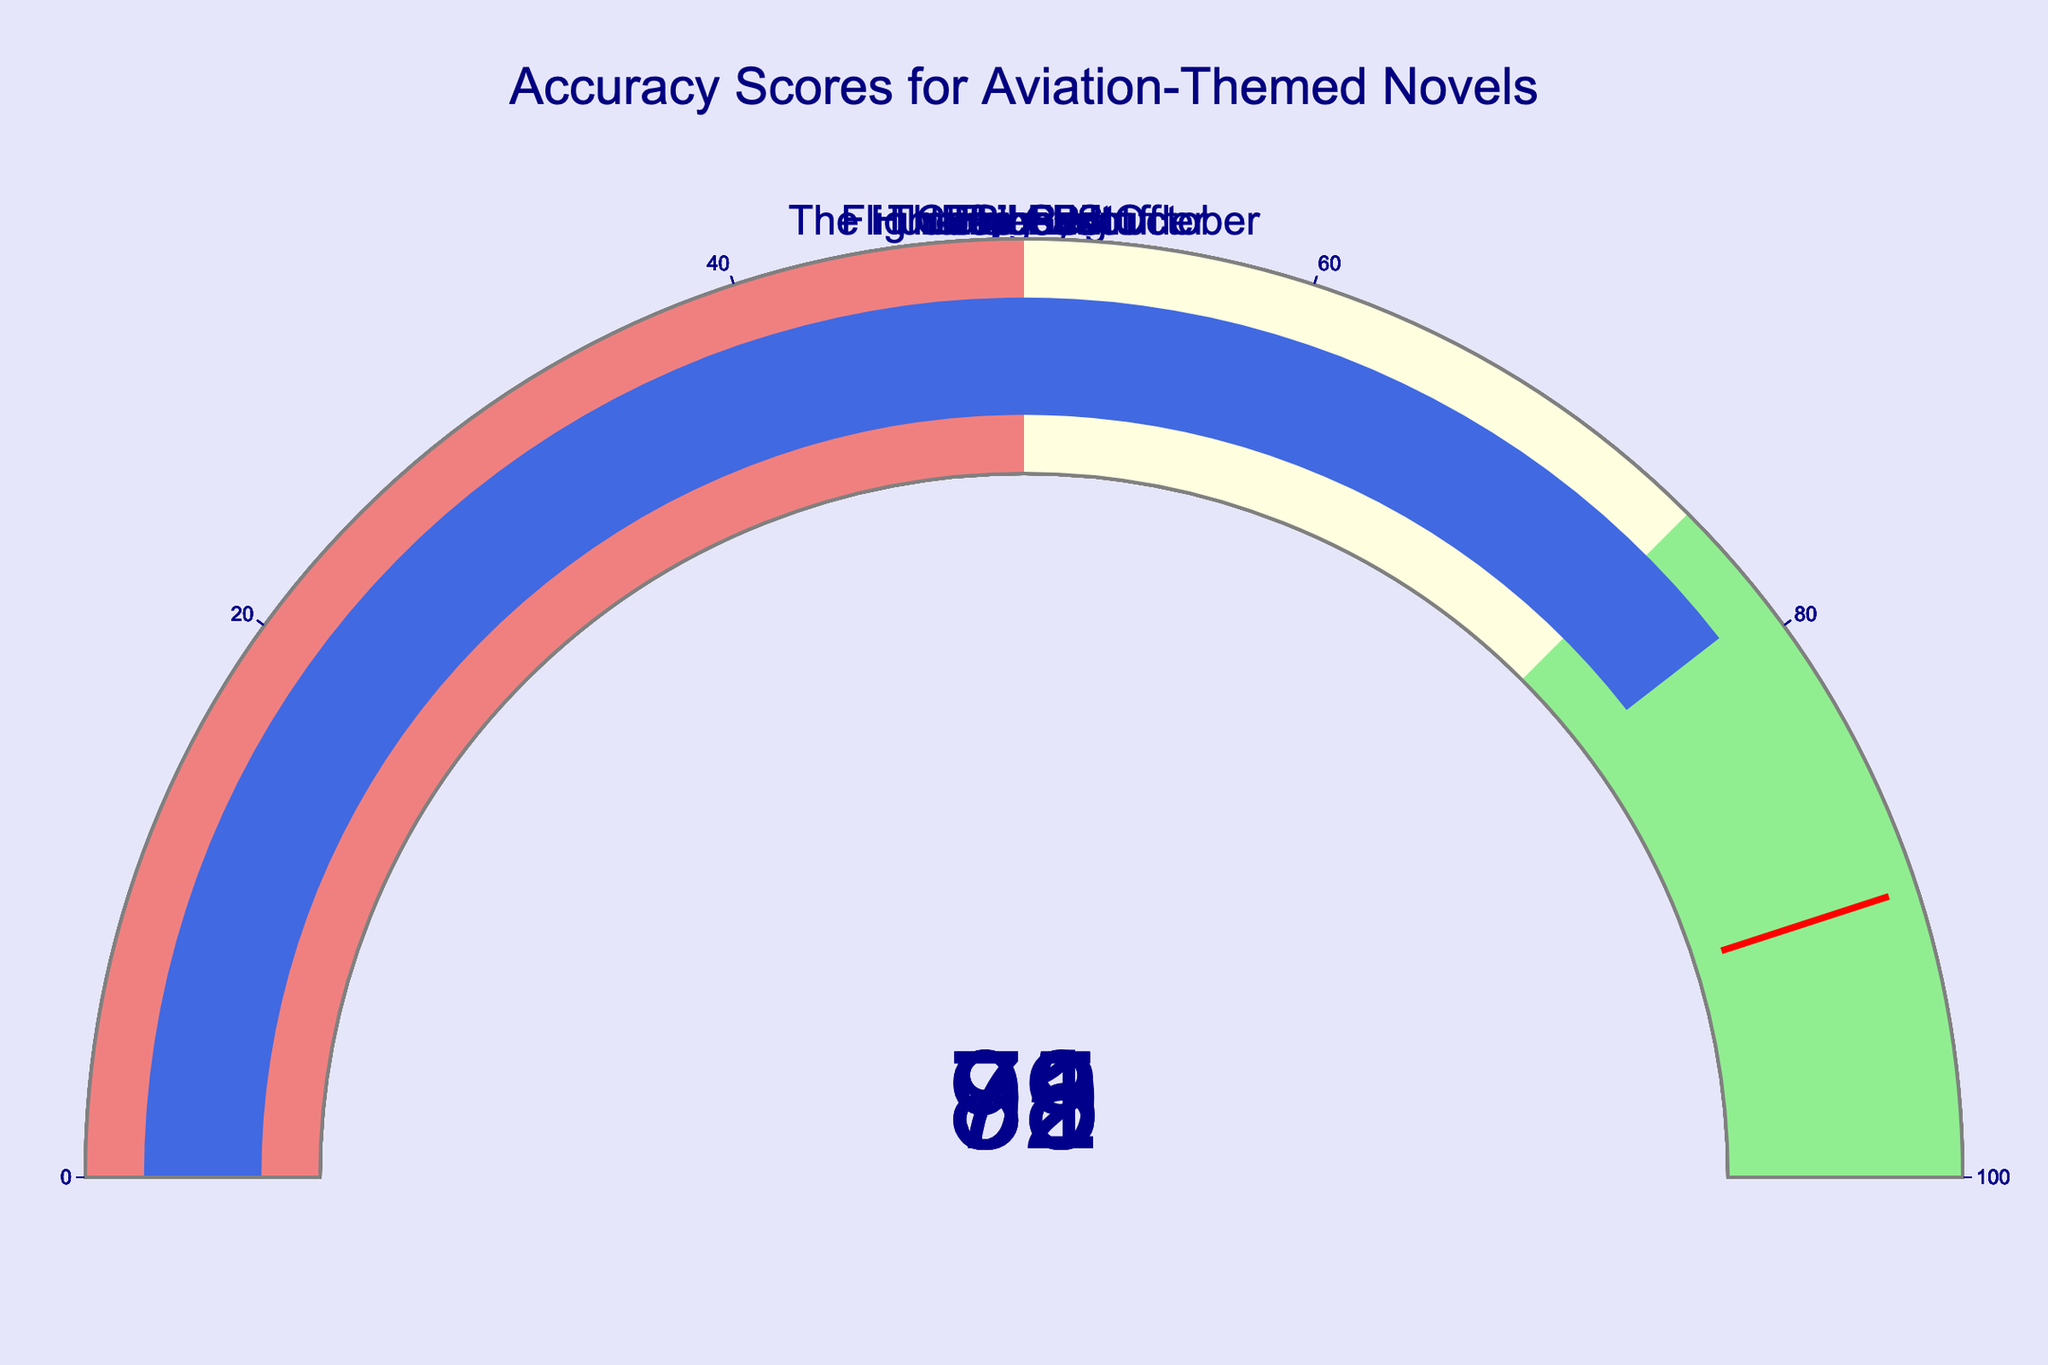What is the Accuracy Score of "Flyboys"? According to the gauge chart, the number displayed for "Flyboys" is 78.
Answer: 78 How many novels have an Accuracy Score above 90? From the gauge chart, the novels "The Right Stuff," "Flight of the Intruder," and "Carrier Pilot" have scores of 95, 92, and 91 respectively.
Answer: 3 Which novel has the highest Accuracy Score, and what is it? Observing the gauge chart, "The Right Stuff" has the highest Accuracy Score with a value of 95.
Answer: The Right Stuff, 95 Are there any novels with an Accuracy Score lower than 80? If so, which ones and what are their scores? The novels "Flyboys" and "Jarhead" have Accuracy Scores under 80, with scores of 78 and 79 respectively.
Answer: Flyboys: 78, Jarhead: 79 What is the average Accuracy Score of all the novels? Adding the scores (85 + 92 + 78 + 95 + 88 + 91 + 82 + 79) gives 690. Dividing by the number of novels (8), the average score is 86.25.
Answer: 86.25 What's the difference in Accuracy Score between "Top Gun" and "The Hunt for Red October"? "Top Gun" has a score of 85, and "The Hunt for Red October" has a score of 82. The difference is 85 - 82 = 3.
Answer: 3 Which novels have a score within the "lightgreen" range (75-100)? "Top Gun," "Flight of the Intruder," "The Right Stuff," "Red Flag," "Carrier Pilot," and "The Hunt for Red October" have scores in the range of 75-100.
Answer: Top Gun, Flight of the Intruder, The Right Stuff, Red Flag, Carrier Pilot, The Hunt for Red October Is there any novel with an exact score of 90? The gauge chart indicates that no novel has an exact Accuracy Score of 90.
Answer: No What is the sum of the Accuracy Scores of the novels "Top Gun" and "Red Flag"? "Top Gun" has a score of 85, and "Red Flag" has a score of 88. The sum is 85 + 88 = 173.
Answer: 173 Which novels are close to hitting the threshold value of 90 with their Accuracy Scores? "Carrier Pilot" and "Flight of the Intruder" have scores very close to 90, with 91 and 92 respectively.
Answer: Carrier Pilot, Flight of the Intruder 